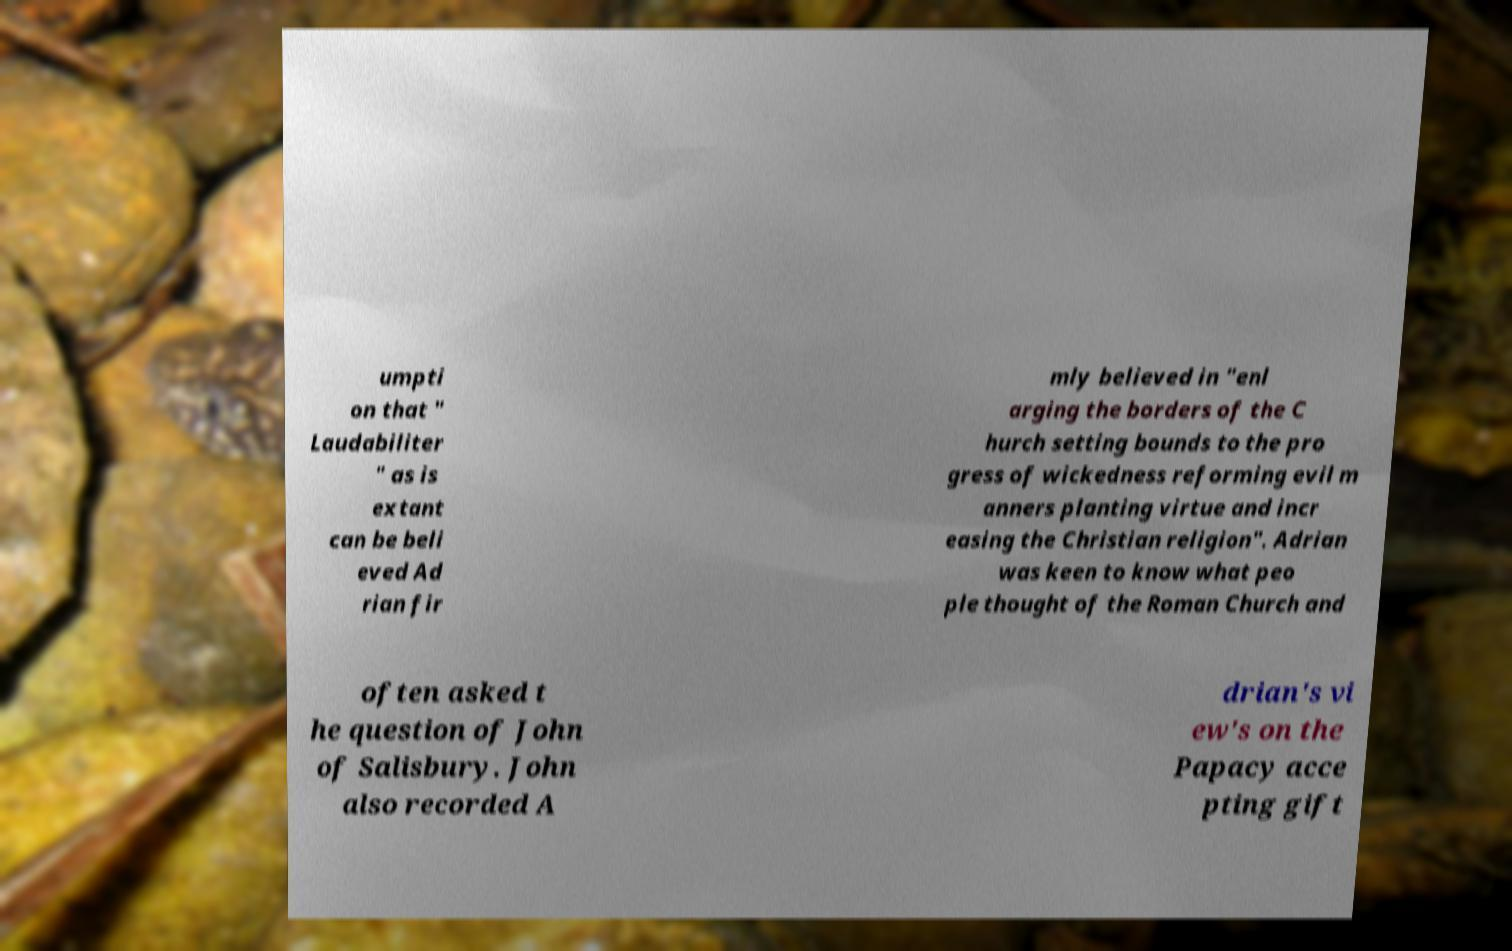Please identify and transcribe the text found in this image. umpti on that " Laudabiliter " as is extant can be beli eved Ad rian fir mly believed in "enl arging the borders of the C hurch setting bounds to the pro gress of wickedness reforming evil m anners planting virtue and incr easing the Christian religion". Adrian was keen to know what peo ple thought of the Roman Church and often asked t he question of John of Salisbury. John also recorded A drian's vi ew's on the Papacy acce pting gift 